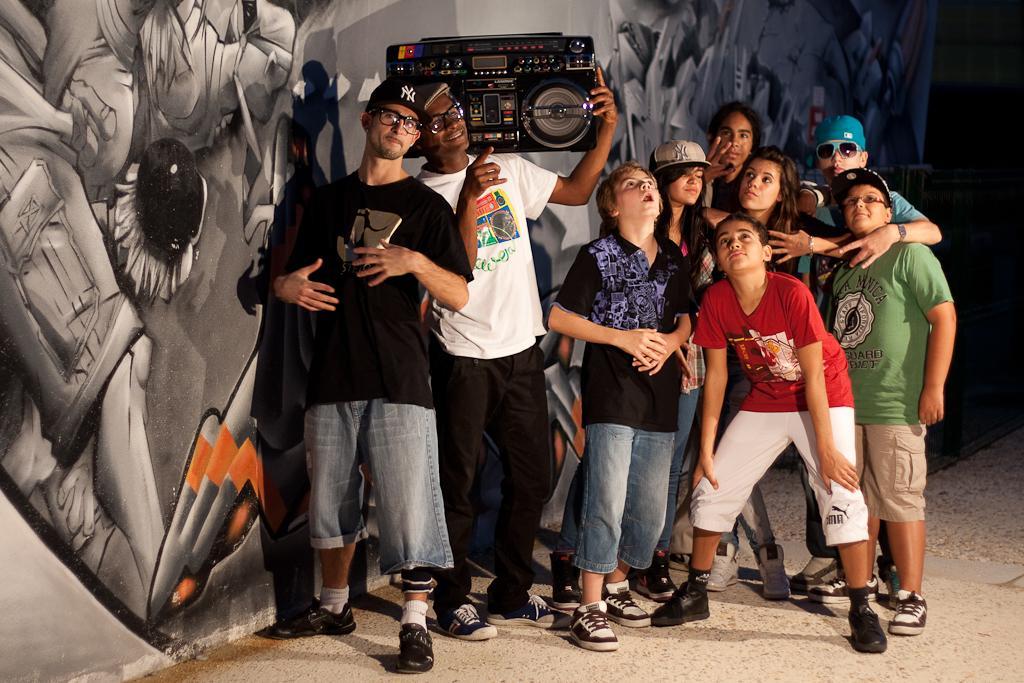In one or two sentences, can you explain what this image depicts? In this image we can see a group of people standing on the ground. One person is holding a device with his hand. In the background, we can see some painting on the wall 